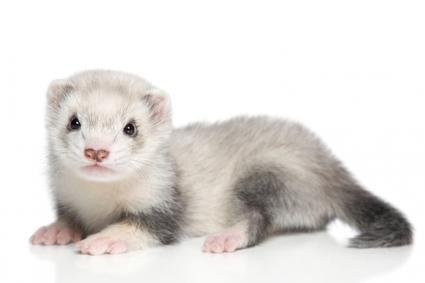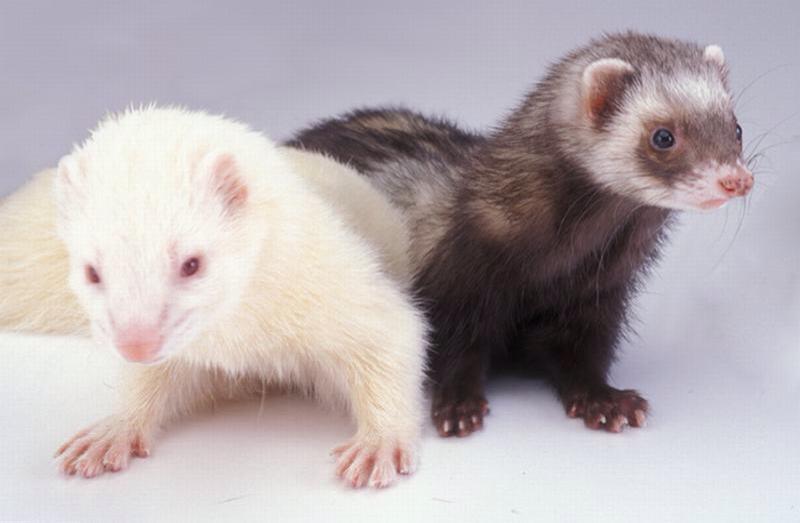The first image is the image on the left, the second image is the image on the right. Examine the images to the left and right. Is the description "One image contains a pair of ferrets." accurate? Answer yes or no. Yes. 